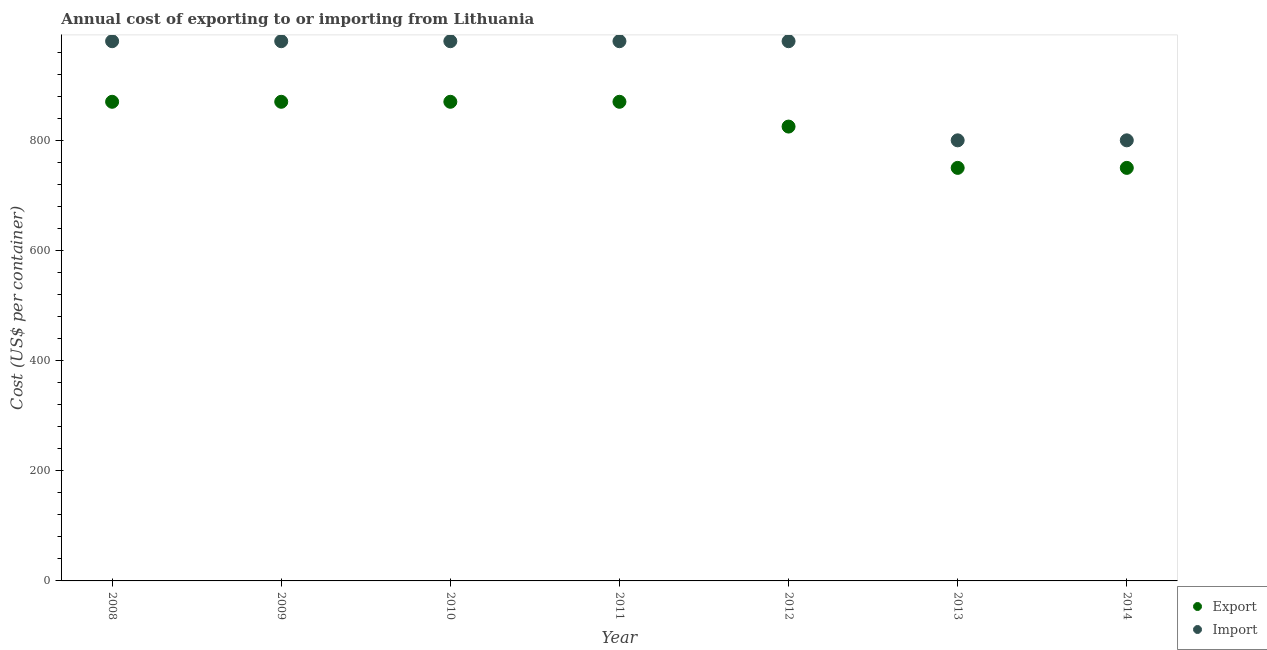How many different coloured dotlines are there?
Make the answer very short. 2. Is the number of dotlines equal to the number of legend labels?
Your response must be concise. Yes. What is the import cost in 2009?
Give a very brief answer. 980. Across all years, what is the maximum export cost?
Ensure brevity in your answer.  870. Across all years, what is the minimum export cost?
Keep it short and to the point. 750. In which year was the export cost maximum?
Your answer should be very brief. 2008. What is the total export cost in the graph?
Ensure brevity in your answer.  5805. What is the difference between the export cost in 2008 and that in 2013?
Offer a terse response. 120. What is the difference between the import cost in 2012 and the export cost in 2013?
Give a very brief answer. 230. What is the average export cost per year?
Provide a succinct answer. 829.29. In the year 2013, what is the difference between the export cost and import cost?
Make the answer very short. -50. In how many years, is the export cost greater than 760 US$?
Offer a terse response. 5. What is the ratio of the export cost in 2011 to that in 2014?
Your answer should be very brief. 1.16. Is the import cost in 2008 less than that in 2012?
Your answer should be compact. No. What is the difference between the highest and the lowest import cost?
Offer a terse response. 180. In how many years, is the export cost greater than the average export cost taken over all years?
Keep it short and to the point. 4. Is the sum of the import cost in 2012 and 2013 greater than the maximum export cost across all years?
Provide a succinct answer. Yes. Is the export cost strictly less than the import cost over the years?
Give a very brief answer. Yes. How many years are there in the graph?
Offer a very short reply. 7. Does the graph contain any zero values?
Offer a terse response. No. Where does the legend appear in the graph?
Offer a terse response. Bottom right. What is the title of the graph?
Your response must be concise. Annual cost of exporting to or importing from Lithuania. Does "Gasoline" appear as one of the legend labels in the graph?
Provide a succinct answer. No. What is the label or title of the X-axis?
Ensure brevity in your answer.  Year. What is the label or title of the Y-axis?
Give a very brief answer. Cost (US$ per container). What is the Cost (US$ per container) of Export in 2008?
Provide a succinct answer. 870. What is the Cost (US$ per container) in Import in 2008?
Make the answer very short. 980. What is the Cost (US$ per container) of Export in 2009?
Provide a succinct answer. 870. What is the Cost (US$ per container) of Import in 2009?
Offer a terse response. 980. What is the Cost (US$ per container) in Export in 2010?
Provide a succinct answer. 870. What is the Cost (US$ per container) in Import in 2010?
Offer a terse response. 980. What is the Cost (US$ per container) in Export in 2011?
Ensure brevity in your answer.  870. What is the Cost (US$ per container) in Import in 2011?
Provide a succinct answer. 980. What is the Cost (US$ per container) in Export in 2012?
Offer a terse response. 825. What is the Cost (US$ per container) in Import in 2012?
Your answer should be very brief. 980. What is the Cost (US$ per container) in Export in 2013?
Your answer should be compact. 750. What is the Cost (US$ per container) in Import in 2013?
Offer a very short reply. 800. What is the Cost (US$ per container) in Export in 2014?
Ensure brevity in your answer.  750. What is the Cost (US$ per container) in Import in 2014?
Your response must be concise. 800. Across all years, what is the maximum Cost (US$ per container) of Export?
Provide a succinct answer. 870. Across all years, what is the maximum Cost (US$ per container) of Import?
Ensure brevity in your answer.  980. Across all years, what is the minimum Cost (US$ per container) in Export?
Your answer should be very brief. 750. Across all years, what is the minimum Cost (US$ per container) of Import?
Offer a very short reply. 800. What is the total Cost (US$ per container) in Export in the graph?
Provide a succinct answer. 5805. What is the total Cost (US$ per container) of Import in the graph?
Provide a succinct answer. 6500. What is the difference between the Cost (US$ per container) in Import in 2008 and that in 2009?
Your response must be concise. 0. What is the difference between the Cost (US$ per container) of Export in 2008 and that in 2011?
Ensure brevity in your answer.  0. What is the difference between the Cost (US$ per container) of Import in 2008 and that in 2012?
Your answer should be very brief. 0. What is the difference between the Cost (US$ per container) in Export in 2008 and that in 2013?
Give a very brief answer. 120. What is the difference between the Cost (US$ per container) of Import in 2008 and that in 2013?
Your answer should be very brief. 180. What is the difference between the Cost (US$ per container) of Export in 2008 and that in 2014?
Offer a very short reply. 120. What is the difference between the Cost (US$ per container) of Import in 2008 and that in 2014?
Provide a short and direct response. 180. What is the difference between the Cost (US$ per container) of Export in 2009 and that in 2010?
Provide a succinct answer. 0. What is the difference between the Cost (US$ per container) of Import in 2009 and that in 2010?
Provide a succinct answer. 0. What is the difference between the Cost (US$ per container) of Import in 2009 and that in 2011?
Give a very brief answer. 0. What is the difference between the Cost (US$ per container) of Export in 2009 and that in 2012?
Your answer should be compact. 45. What is the difference between the Cost (US$ per container) of Export in 2009 and that in 2013?
Offer a very short reply. 120. What is the difference between the Cost (US$ per container) in Import in 2009 and that in 2013?
Your response must be concise. 180. What is the difference between the Cost (US$ per container) of Export in 2009 and that in 2014?
Offer a very short reply. 120. What is the difference between the Cost (US$ per container) in Import in 2009 and that in 2014?
Your answer should be very brief. 180. What is the difference between the Cost (US$ per container) of Import in 2010 and that in 2011?
Offer a very short reply. 0. What is the difference between the Cost (US$ per container) of Export in 2010 and that in 2012?
Provide a short and direct response. 45. What is the difference between the Cost (US$ per container) in Import in 2010 and that in 2012?
Offer a very short reply. 0. What is the difference between the Cost (US$ per container) in Export in 2010 and that in 2013?
Your answer should be compact. 120. What is the difference between the Cost (US$ per container) in Import in 2010 and that in 2013?
Provide a succinct answer. 180. What is the difference between the Cost (US$ per container) in Export in 2010 and that in 2014?
Your response must be concise. 120. What is the difference between the Cost (US$ per container) of Import in 2010 and that in 2014?
Offer a terse response. 180. What is the difference between the Cost (US$ per container) in Export in 2011 and that in 2013?
Offer a very short reply. 120. What is the difference between the Cost (US$ per container) in Import in 2011 and that in 2013?
Provide a short and direct response. 180. What is the difference between the Cost (US$ per container) in Export in 2011 and that in 2014?
Provide a short and direct response. 120. What is the difference between the Cost (US$ per container) in Import in 2011 and that in 2014?
Offer a terse response. 180. What is the difference between the Cost (US$ per container) in Import in 2012 and that in 2013?
Your answer should be very brief. 180. What is the difference between the Cost (US$ per container) of Import in 2012 and that in 2014?
Your answer should be very brief. 180. What is the difference between the Cost (US$ per container) in Export in 2013 and that in 2014?
Give a very brief answer. 0. What is the difference between the Cost (US$ per container) in Export in 2008 and the Cost (US$ per container) in Import in 2009?
Provide a short and direct response. -110. What is the difference between the Cost (US$ per container) of Export in 2008 and the Cost (US$ per container) of Import in 2010?
Make the answer very short. -110. What is the difference between the Cost (US$ per container) of Export in 2008 and the Cost (US$ per container) of Import in 2011?
Offer a very short reply. -110. What is the difference between the Cost (US$ per container) of Export in 2008 and the Cost (US$ per container) of Import in 2012?
Make the answer very short. -110. What is the difference between the Cost (US$ per container) of Export in 2009 and the Cost (US$ per container) of Import in 2010?
Give a very brief answer. -110. What is the difference between the Cost (US$ per container) of Export in 2009 and the Cost (US$ per container) of Import in 2011?
Ensure brevity in your answer.  -110. What is the difference between the Cost (US$ per container) of Export in 2009 and the Cost (US$ per container) of Import in 2012?
Your answer should be compact. -110. What is the difference between the Cost (US$ per container) in Export in 2009 and the Cost (US$ per container) in Import in 2013?
Offer a very short reply. 70. What is the difference between the Cost (US$ per container) of Export in 2010 and the Cost (US$ per container) of Import in 2011?
Provide a succinct answer. -110. What is the difference between the Cost (US$ per container) of Export in 2010 and the Cost (US$ per container) of Import in 2012?
Your answer should be compact. -110. What is the difference between the Cost (US$ per container) of Export in 2010 and the Cost (US$ per container) of Import in 2014?
Ensure brevity in your answer.  70. What is the difference between the Cost (US$ per container) of Export in 2011 and the Cost (US$ per container) of Import in 2012?
Offer a terse response. -110. What is the difference between the Cost (US$ per container) in Export in 2011 and the Cost (US$ per container) in Import in 2014?
Your answer should be compact. 70. What is the difference between the Cost (US$ per container) in Export in 2012 and the Cost (US$ per container) in Import in 2014?
Keep it short and to the point. 25. What is the average Cost (US$ per container) of Export per year?
Make the answer very short. 829.29. What is the average Cost (US$ per container) in Import per year?
Make the answer very short. 928.57. In the year 2008, what is the difference between the Cost (US$ per container) in Export and Cost (US$ per container) in Import?
Ensure brevity in your answer.  -110. In the year 2009, what is the difference between the Cost (US$ per container) in Export and Cost (US$ per container) in Import?
Keep it short and to the point. -110. In the year 2010, what is the difference between the Cost (US$ per container) of Export and Cost (US$ per container) of Import?
Give a very brief answer. -110. In the year 2011, what is the difference between the Cost (US$ per container) of Export and Cost (US$ per container) of Import?
Your response must be concise. -110. In the year 2012, what is the difference between the Cost (US$ per container) of Export and Cost (US$ per container) of Import?
Give a very brief answer. -155. In the year 2013, what is the difference between the Cost (US$ per container) of Export and Cost (US$ per container) of Import?
Give a very brief answer. -50. What is the ratio of the Cost (US$ per container) of Export in 2008 to that in 2010?
Give a very brief answer. 1. What is the ratio of the Cost (US$ per container) of Import in 2008 to that in 2010?
Ensure brevity in your answer.  1. What is the ratio of the Cost (US$ per container) in Export in 2008 to that in 2012?
Your answer should be very brief. 1.05. What is the ratio of the Cost (US$ per container) of Import in 2008 to that in 2012?
Offer a very short reply. 1. What is the ratio of the Cost (US$ per container) of Export in 2008 to that in 2013?
Your response must be concise. 1.16. What is the ratio of the Cost (US$ per container) of Import in 2008 to that in 2013?
Your response must be concise. 1.23. What is the ratio of the Cost (US$ per container) of Export in 2008 to that in 2014?
Make the answer very short. 1.16. What is the ratio of the Cost (US$ per container) in Import in 2008 to that in 2014?
Offer a terse response. 1.23. What is the ratio of the Cost (US$ per container) of Import in 2009 to that in 2010?
Provide a short and direct response. 1. What is the ratio of the Cost (US$ per container) in Export in 2009 to that in 2011?
Make the answer very short. 1. What is the ratio of the Cost (US$ per container) in Import in 2009 to that in 2011?
Provide a short and direct response. 1. What is the ratio of the Cost (US$ per container) in Export in 2009 to that in 2012?
Provide a succinct answer. 1.05. What is the ratio of the Cost (US$ per container) of Export in 2009 to that in 2013?
Your answer should be very brief. 1.16. What is the ratio of the Cost (US$ per container) in Import in 2009 to that in 2013?
Your response must be concise. 1.23. What is the ratio of the Cost (US$ per container) of Export in 2009 to that in 2014?
Provide a succinct answer. 1.16. What is the ratio of the Cost (US$ per container) of Import in 2009 to that in 2014?
Provide a short and direct response. 1.23. What is the ratio of the Cost (US$ per container) of Export in 2010 to that in 2012?
Ensure brevity in your answer.  1.05. What is the ratio of the Cost (US$ per container) of Export in 2010 to that in 2013?
Give a very brief answer. 1.16. What is the ratio of the Cost (US$ per container) of Import in 2010 to that in 2013?
Make the answer very short. 1.23. What is the ratio of the Cost (US$ per container) of Export in 2010 to that in 2014?
Ensure brevity in your answer.  1.16. What is the ratio of the Cost (US$ per container) of Import in 2010 to that in 2014?
Your answer should be very brief. 1.23. What is the ratio of the Cost (US$ per container) of Export in 2011 to that in 2012?
Ensure brevity in your answer.  1.05. What is the ratio of the Cost (US$ per container) in Import in 2011 to that in 2012?
Give a very brief answer. 1. What is the ratio of the Cost (US$ per container) of Export in 2011 to that in 2013?
Your answer should be compact. 1.16. What is the ratio of the Cost (US$ per container) in Import in 2011 to that in 2013?
Give a very brief answer. 1.23. What is the ratio of the Cost (US$ per container) in Export in 2011 to that in 2014?
Ensure brevity in your answer.  1.16. What is the ratio of the Cost (US$ per container) in Import in 2011 to that in 2014?
Provide a succinct answer. 1.23. What is the ratio of the Cost (US$ per container) in Import in 2012 to that in 2013?
Offer a very short reply. 1.23. What is the ratio of the Cost (US$ per container) in Import in 2012 to that in 2014?
Offer a terse response. 1.23. What is the ratio of the Cost (US$ per container) in Export in 2013 to that in 2014?
Give a very brief answer. 1. What is the ratio of the Cost (US$ per container) of Import in 2013 to that in 2014?
Give a very brief answer. 1. What is the difference between the highest and the lowest Cost (US$ per container) of Export?
Offer a terse response. 120. What is the difference between the highest and the lowest Cost (US$ per container) in Import?
Make the answer very short. 180. 